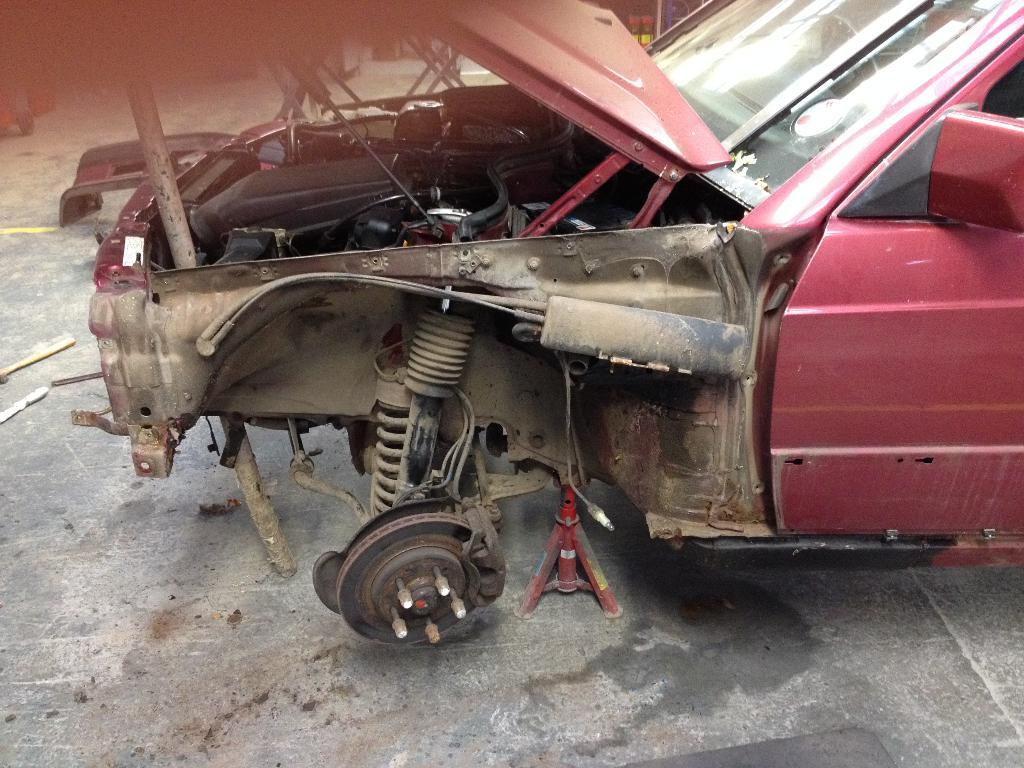What is the main subject in the center of the image? There is a red color vehicle in the center of the image. What can be seen in the foreground of the image? The ground is visible in the foreground of the image. What is present in the background of the image? There are some objects in the background of the image. What type of milk is being used to improve the acoustics of the vehicle in the image? There is no mention of milk or acoustics in the image, and the image does not show any improvement being made to the vehicle. 